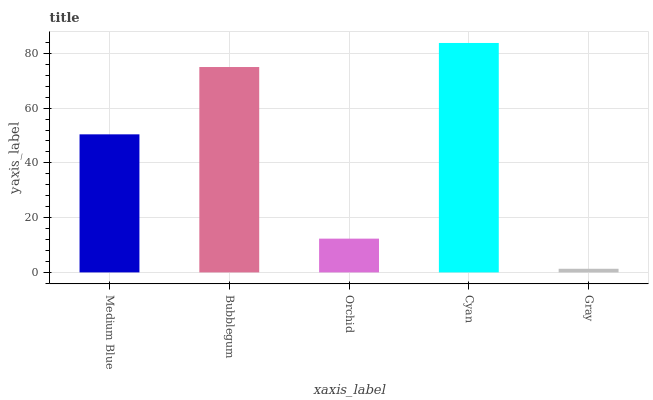Is Gray the minimum?
Answer yes or no. Yes. Is Cyan the maximum?
Answer yes or no. Yes. Is Bubblegum the minimum?
Answer yes or no. No. Is Bubblegum the maximum?
Answer yes or no. No. Is Bubblegum greater than Medium Blue?
Answer yes or no. Yes. Is Medium Blue less than Bubblegum?
Answer yes or no. Yes. Is Medium Blue greater than Bubblegum?
Answer yes or no. No. Is Bubblegum less than Medium Blue?
Answer yes or no. No. Is Medium Blue the high median?
Answer yes or no. Yes. Is Medium Blue the low median?
Answer yes or no. Yes. Is Bubblegum the high median?
Answer yes or no. No. Is Orchid the low median?
Answer yes or no. No. 